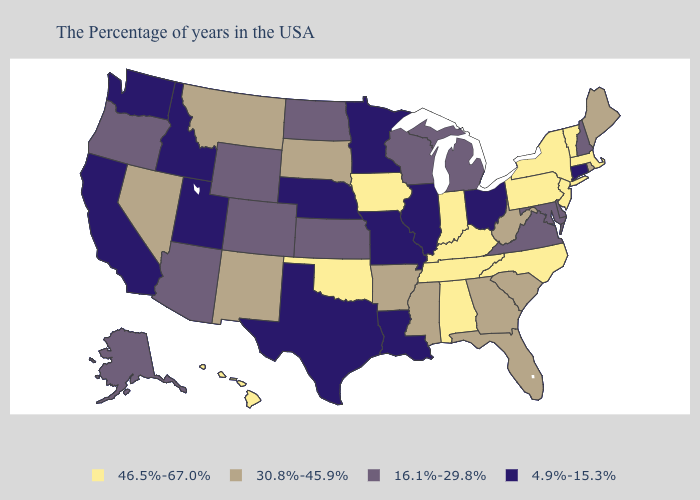Does the first symbol in the legend represent the smallest category?
Answer briefly. No. Which states have the lowest value in the USA?
Quick response, please. Connecticut, Ohio, Illinois, Louisiana, Missouri, Minnesota, Nebraska, Texas, Utah, Idaho, California, Washington. Name the states that have a value in the range 16.1%-29.8%?
Be succinct. New Hampshire, Delaware, Maryland, Virginia, Michigan, Wisconsin, Kansas, North Dakota, Wyoming, Colorado, Arizona, Oregon, Alaska. What is the lowest value in the MidWest?
Be succinct. 4.9%-15.3%. What is the highest value in the Northeast ?
Concise answer only. 46.5%-67.0%. Name the states that have a value in the range 4.9%-15.3%?
Give a very brief answer. Connecticut, Ohio, Illinois, Louisiana, Missouri, Minnesota, Nebraska, Texas, Utah, Idaho, California, Washington. Among the states that border Indiana , which have the highest value?
Answer briefly. Kentucky. What is the highest value in states that border Vermont?
Keep it brief. 46.5%-67.0%. Name the states that have a value in the range 4.9%-15.3%?
Write a very short answer. Connecticut, Ohio, Illinois, Louisiana, Missouri, Minnesota, Nebraska, Texas, Utah, Idaho, California, Washington. Does the map have missing data?
Be succinct. No. What is the value of West Virginia?
Concise answer only. 30.8%-45.9%. Among the states that border Vermont , does New Hampshire have the lowest value?
Quick response, please. Yes. Does West Virginia have the lowest value in the USA?
Keep it brief. No. Does the first symbol in the legend represent the smallest category?
Answer briefly. No. 